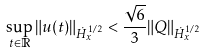<formula> <loc_0><loc_0><loc_500><loc_500>\sup _ { t \in \mathbb { R } } \| u ( t ) \| _ { \dot { H } ^ { 1 / 2 } _ { x } } < \frac { \sqrt { 6 } } { 3 } \| Q \| _ { \dot { H } ^ { 1 / 2 } _ { x } }</formula> 